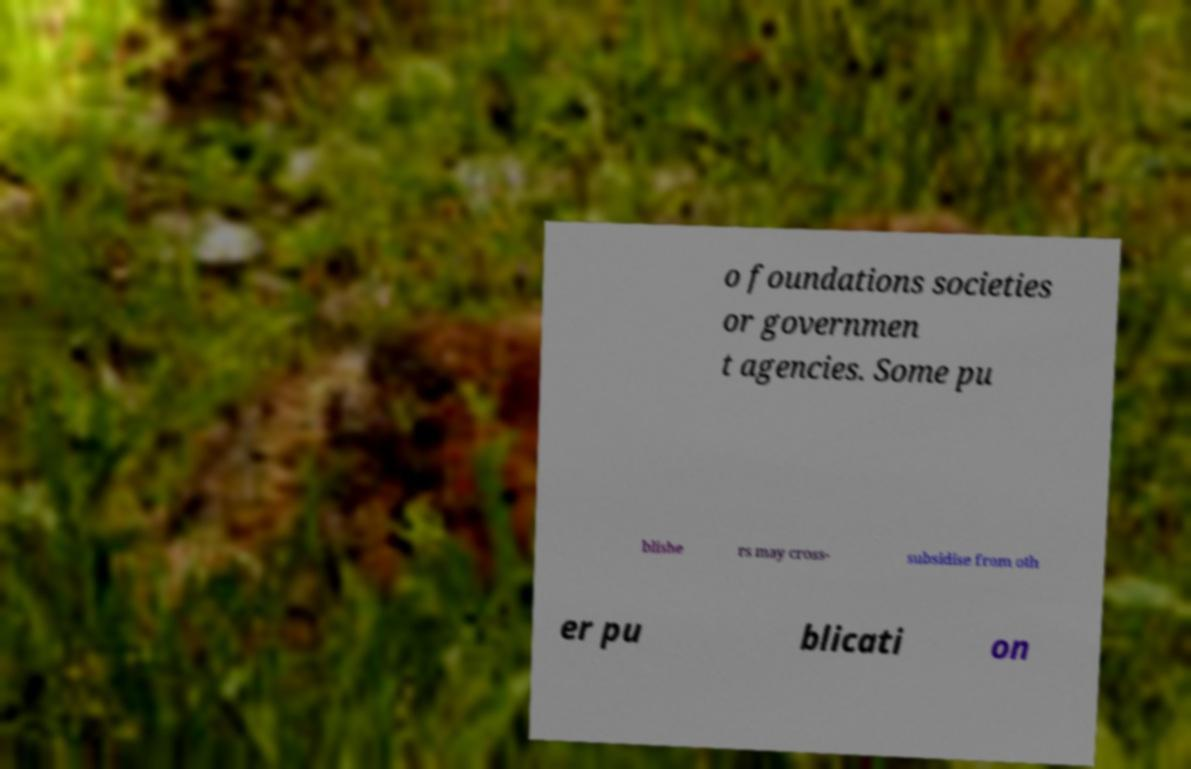Can you accurately transcribe the text from the provided image for me? o foundations societies or governmen t agencies. Some pu blishe rs may cross- subsidise from oth er pu blicati on 